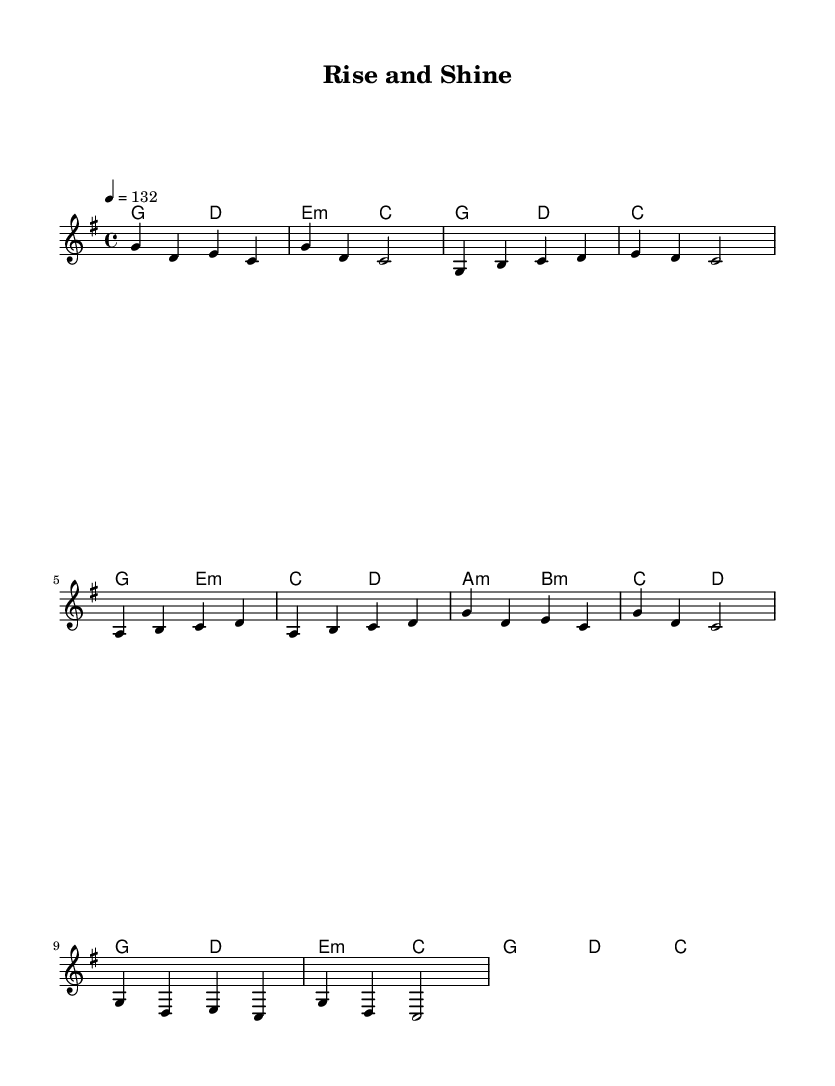What is the key signature of this music? The key signature is G major, which has one sharp (F#).
Answer: G major What is the time signature of this music? The time signature is 4/4, indicating that there are four beats in each measure and a quarter note gets one beat.
Answer: 4/4 What is the tempo marking for this music? The tempo marking is indicated as "4 = 132," which means there are 132 beats per minute.
Answer: 132 How many measures are there in the pre-chorus section? The pre-chorus consists of four measures, as indicated by the four lines of music for that section.
Answer: four Which chord follows the G major chord in the intro? In the intro, the chord that follows the G major is D major.
Answer: D major What is the structure of the song based on the sections provided? The structure consists of an Intro, Verse 1, Pre-Chorus, and Chorus, which is typical for K-Pop song formatting.
Answer: Intro, Verse 1, Pre-Chorus, Chorus What distinctive characteristic would you expect to find in K-Pop melodies that is present here? Energetic melodies with memorable hooks are characteristic of K-Pop, and this song features such a melodic structure.
Answer: energetic 